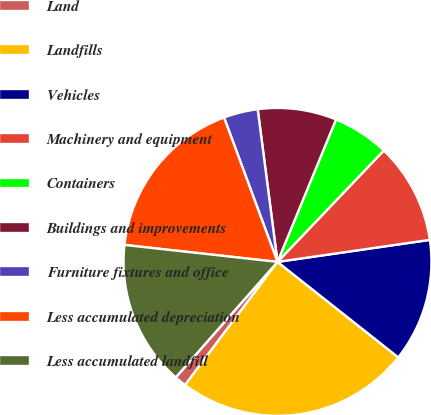Convert chart to OTSL. <chart><loc_0><loc_0><loc_500><loc_500><pie_chart><fcel>Land<fcel>Landfills<fcel>Vehicles<fcel>Machinery and equipment<fcel>Containers<fcel>Buildings and improvements<fcel>Furniture fixtures and office<fcel>Less accumulated depreciation<fcel>Less accumulated landfill<nl><fcel>1.25%<fcel>24.6%<fcel>12.93%<fcel>10.59%<fcel>5.92%<fcel>8.26%<fcel>3.59%<fcel>17.6%<fcel>15.26%<nl></chart> 